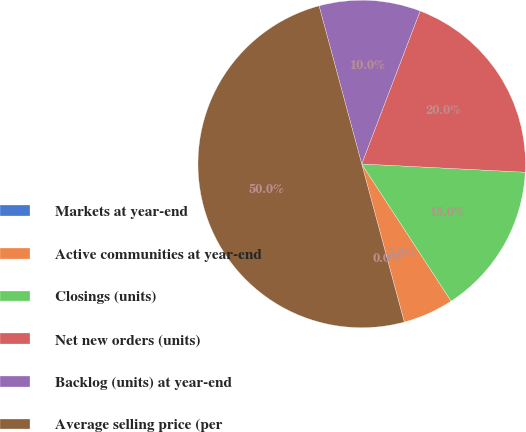Convert chart. <chart><loc_0><loc_0><loc_500><loc_500><pie_chart><fcel>Markets at year-end<fcel>Active communities at year-end<fcel>Closings (units)<fcel>Net new orders (units)<fcel>Backlog (units) at year-end<fcel>Average selling price (per<nl><fcel>0.01%<fcel>5.0%<fcel>15.0%<fcel>20.0%<fcel>10.0%<fcel>49.99%<nl></chart> 